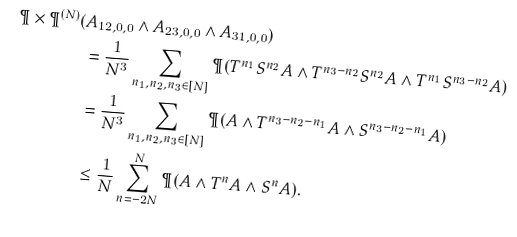Convert formula to latex. <formula><loc_0><loc_0><loc_500><loc_500>\P \times \P ^ { ( N ) } ( & A _ { 1 2 , 0 , 0 } \wedge A _ { 2 3 , 0 , 0 } \wedge A _ { 3 1 , 0 , 0 } ) \\ & = \frac { 1 } { N ^ { 3 } } \sum _ { n _ { 1 } , n _ { 2 } , n _ { 3 } \in [ N ] } \P ( T ^ { n _ { 1 } } S ^ { n _ { 2 } } A \wedge T ^ { n _ { 3 } - n _ { 2 } } S ^ { n _ { 2 } } A \wedge T ^ { n _ { 1 } } S ^ { n _ { 3 } - n _ { 2 } } A ) \\ & = \frac { 1 } { N ^ { 3 } } \sum _ { n _ { 1 } , n _ { 2 } , n _ { 3 } \in [ N ] } \P ( A \wedge T ^ { n _ { 3 } - n _ { 2 } - n _ { 1 } } A \wedge S ^ { n _ { 3 } - n _ { 2 } - n _ { 1 } } A ) \\ & \leq \frac { 1 } { N } \sum _ { n = - 2 N } ^ { N } \P ( A \wedge T ^ { n } A \wedge S ^ { n } A ) .</formula> 